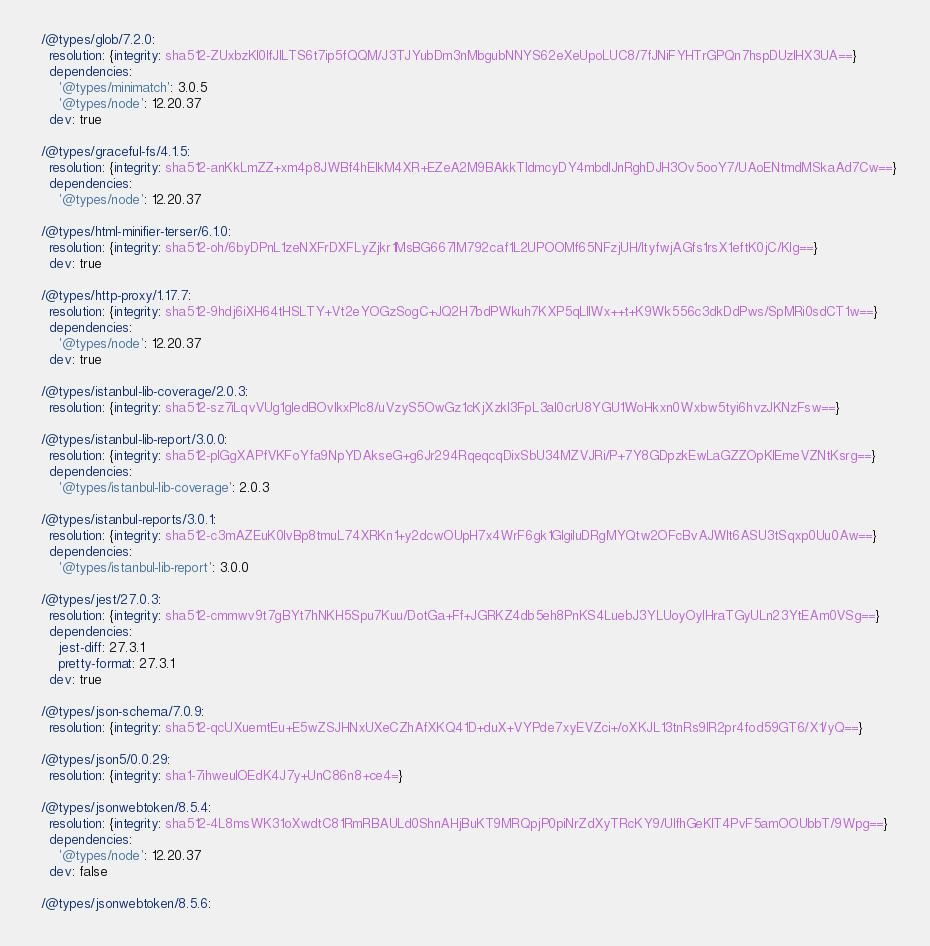<code> <loc_0><loc_0><loc_500><loc_500><_YAML_>
  /@types/glob/7.2.0:
    resolution: {integrity: sha512-ZUxbzKl0IfJILTS6t7ip5fQQM/J3TJYubDm3nMbgubNNYS62eXeUpoLUC8/7fJNiFYHTrGPQn7hspDUzIHX3UA==}
    dependencies:
      '@types/minimatch': 3.0.5
      '@types/node': 12.20.37
    dev: true

  /@types/graceful-fs/4.1.5:
    resolution: {integrity: sha512-anKkLmZZ+xm4p8JWBf4hElkM4XR+EZeA2M9BAkkTldmcyDY4mbdIJnRghDJH3Ov5ooY7/UAoENtmdMSkaAd7Cw==}
    dependencies:
      '@types/node': 12.20.37

  /@types/html-minifier-terser/6.1.0:
    resolution: {integrity: sha512-oh/6byDPnL1zeNXFrDXFLyZjkr1MsBG667IM792caf1L2UPOOMf65NFzjUH/ltyfwjAGfs1rsX1eftK0jC/KIg==}
    dev: true

  /@types/http-proxy/1.17.7:
    resolution: {integrity: sha512-9hdj6iXH64tHSLTY+Vt2eYOGzSogC+JQ2H7bdPWkuh7KXP5qLllWx++t+K9Wk556c3dkDdPws/SpMRi0sdCT1w==}
    dependencies:
      '@types/node': 12.20.37
    dev: true

  /@types/istanbul-lib-coverage/2.0.3:
    resolution: {integrity: sha512-sz7iLqvVUg1gIedBOvlkxPlc8/uVzyS5OwGz1cKjXzkl3FpL3al0crU8YGU1WoHkxn0Wxbw5tyi6hvzJKNzFsw==}

  /@types/istanbul-lib-report/3.0.0:
    resolution: {integrity: sha512-plGgXAPfVKFoYfa9NpYDAkseG+g6Jr294RqeqcqDixSbU34MZVJRi/P+7Y8GDpzkEwLaGZZOpKIEmeVZNtKsrg==}
    dependencies:
      '@types/istanbul-lib-coverage': 2.0.3

  /@types/istanbul-reports/3.0.1:
    resolution: {integrity: sha512-c3mAZEuK0lvBp8tmuL74XRKn1+y2dcwOUpH7x4WrF6gk1GIgiluDRgMYQtw2OFcBvAJWlt6ASU3tSqxp0Uu0Aw==}
    dependencies:
      '@types/istanbul-lib-report': 3.0.0

  /@types/jest/27.0.3:
    resolution: {integrity: sha512-cmmwv9t7gBYt7hNKH5Spu7Kuu/DotGa+Ff+JGRKZ4db5eh8PnKS4LuebJ3YLUoyOyIHraTGyULn23YtEAm0VSg==}
    dependencies:
      jest-diff: 27.3.1
      pretty-format: 27.3.1
    dev: true

  /@types/json-schema/7.0.9:
    resolution: {integrity: sha512-qcUXuemtEu+E5wZSJHNxUXeCZhAfXKQ41D+duX+VYPde7xyEVZci+/oXKJL13tnRs9lR2pr4fod59GT6/X1/yQ==}

  /@types/json5/0.0.29:
    resolution: {integrity: sha1-7ihweulOEdK4J7y+UnC86n8+ce4=}

  /@types/jsonwebtoken/8.5.4:
    resolution: {integrity: sha512-4L8msWK31oXwdtC81RmRBAULd0ShnAHjBuKT9MRQpjP0piNrZdXyTRcKY9/UIfhGeKIT4PvF5amOOUbbT/9Wpg==}
    dependencies:
      '@types/node': 12.20.37
    dev: false

  /@types/jsonwebtoken/8.5.6:</code> 